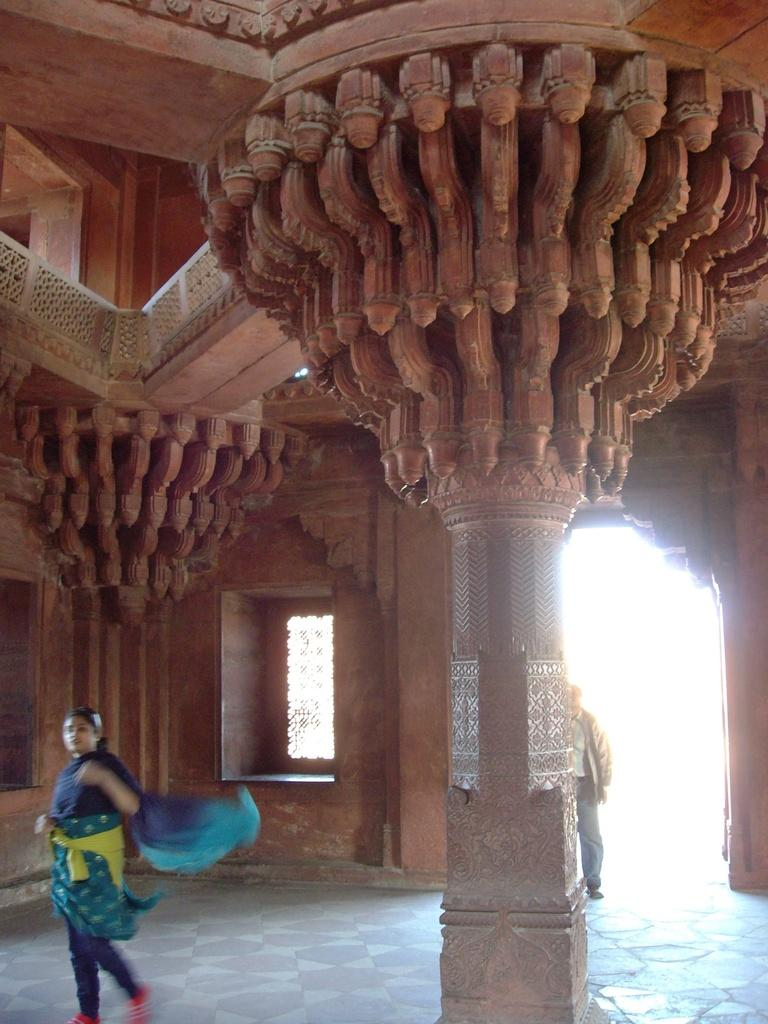What type of location is shown in the image? The image depicts an inside view of a building. Can you describe the people present in the image? There is a woman and a man in the image. What type of brake system is installed in the building shown in the image? There is no information about a brake system in the image, as it depicts an inside view of a building with a woman and a man. 